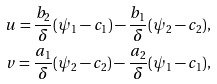<formula> <loc_0><loc_0><loc_500><loc_500>u = \frac { b _ { 2 } } { \delta } ( \psi _ { 1 } - c _ { 1 } ) - \frac { b _ { 1 } } { \delta } ( \psi _ { 2 } - c _ { 2 } ) , \\ v = \frac { a _ { 1 } } { \delta } ( \psi _ { 2 } - c _ { 2 } ) - \frac { a _ { 2 } } { \delta } ( \psi _ { 1 } - c _ { 1 } ) ,</formula> 